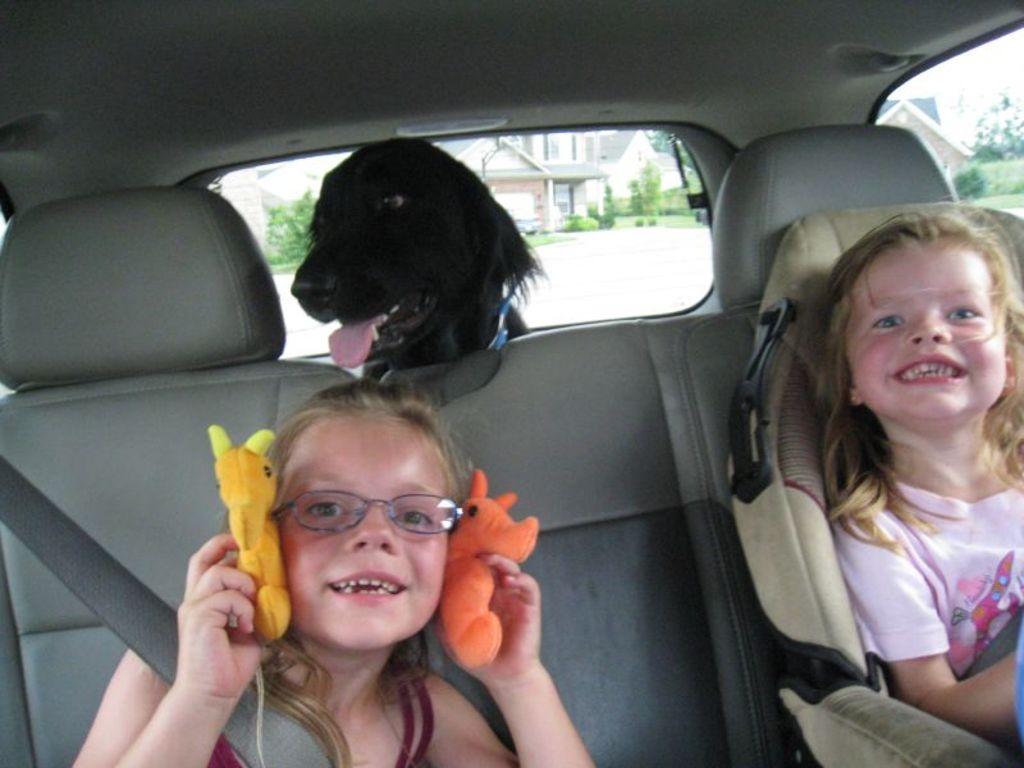Please provide a concise description of this image. There are two small girls sitting inside the car and smiling. This is the black dog inside the car. these are the toys which are in orange and yellow color. At background I can see the house and trees through the car window. 